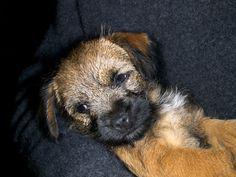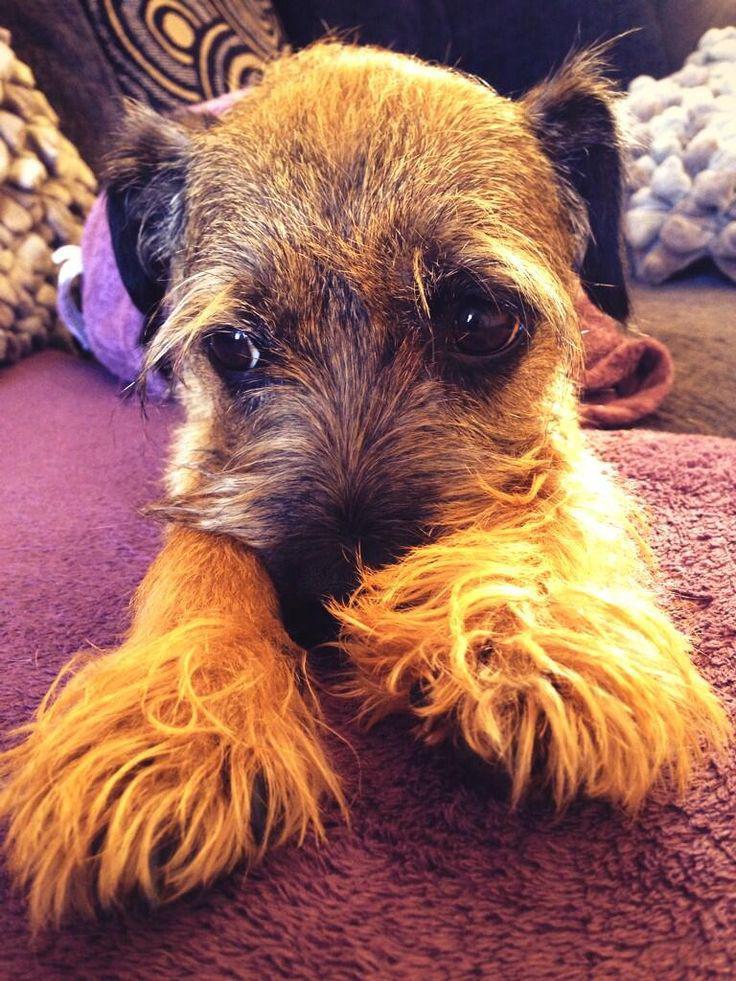The first image is the image on the left, the second image is the image on the right. Examine the images to the left and right. Is the description "One image shows two dogs with their heads close together." accurate? Answer yes or no. No. The first image is the image on the left, the second image is the image on the right. For the images shown, is this caption "There is only one dog in each picture." true? Answer yes or no. Yes. 